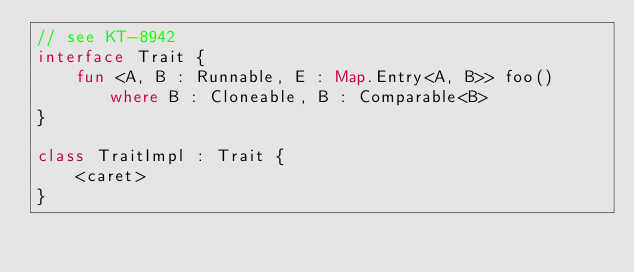<code> <loc_0><loc_0><loc_500><loc_500><_Kotlin_>// see KT-8942
interface Trait {
    fun <A, B : Runnable, E : Map.Entry<A, B>> foo() where B : Cloneable, B : Comparable<B>
}

class TraitImpl : Trait {
    <caret>
}</code> 